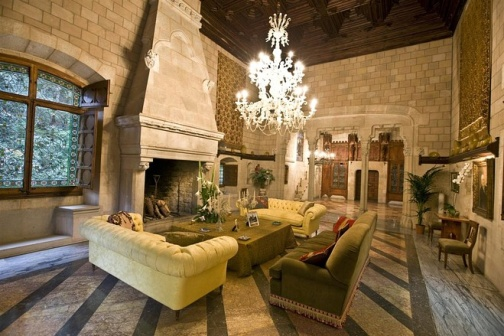What do you think is going on in this snapshot?
 The image showcases a luxurious living room that exudes a sense of grandeur and comfort. Dominating the room is a high ceiling from which a crystal chandelier elegantly hangs, casting a warm glow throughout the space. The ceiling itself is made of wood, adding a rustic charm to the room.

The room features a stone fireplace, a symbol of warmth and hospitality. Atop the mantel of the fireplace rests a vase filled with vibrant flowers. Adjacent to the fireplace, a large window allows natural light to flood the room, offering a glimpse of the lush greenery outside.

A wooden door with a stained glass window adds a touch of vintage elegance to the room. The floor, laid with black and white tiles, contrasts beautifully with the stone walls.

The furniture in the room includes two beige sofas and a red armchair, all arranged around a wooden coffee table. The coffee table holds a vase with flowers, mirroring the one on the fireplace mantel. The arrangement of the furniture invites conversation and social interaction, making the room not just beautiful, but also functional. 